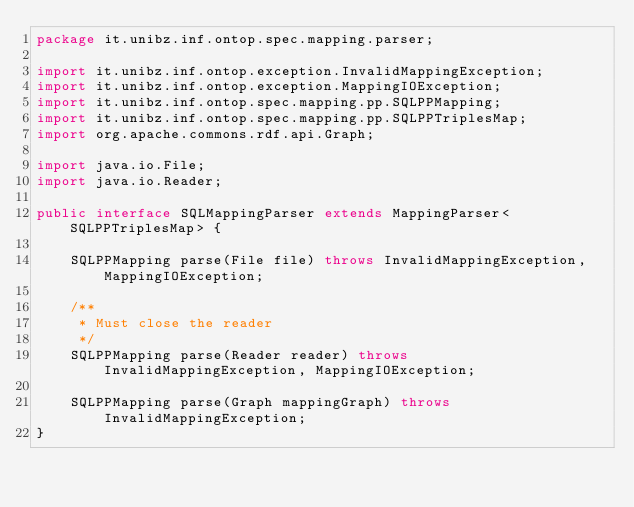<code> <loc_0><loc_0><loc_500><loc_500><_Java_>package it.unibz.inf.ontop.spec.mapping.parser;

import it.unibz.inf.ontop.exception.InvalidMappingException;
import it.unibz.inf.ontop.exception.MappingIOException;
import it.unibz.inf.ontop.spec.mapping.pp.SQLPPMapping;
import it.unibz.inf.ontop.spec.mapping.pp.SQLPPTriplesMap;
import org.apache.commons.rdf.api.Graph;

import java.io.File;
import java.io.Reader;

public interface SQLMappingParser extends MappingParser<SQLPPTriplesMap> {

    SQLPPMapping parse(File file) throws InvalidMappingException, MappingIOException;

    /**
     * Must close the reader
     */
    SQLPPMapping parse(Reader reader) throws InvalidMappingException, MappingIOException;

    SQLPPMapping parse(Graph mappingGraph) throws InvalidMappingException;
}
</code> 